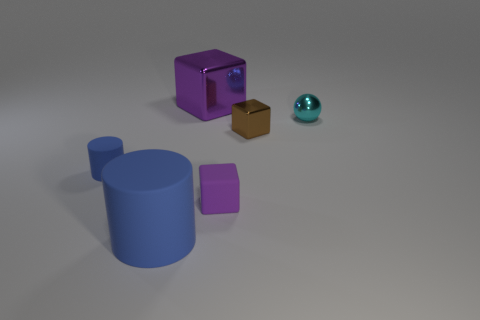There is a purple matte block; are there any big matte cylinders right of it?
Your answer should be very brief. No. What number of other objects are there of the same shape as the small blue object?
Give a very brief answer. 1. The shiny block that is the same size as the cyan sphere is what color?
Provide a succinct answer. Brown. Is the number of brown metal objects that are to the right of the tiny cyan thing less than the number of rubber objects on the left side of the small rubber cube?
Offer a very short reply. Yes. There is a blue matte object on the right side of the small thing that is left of the big metal thing; what number of blue cylinders are left of it?
Provide a short and direct response. 1. What size is the other brown metal object that is the same shape as the big metal object?
Provide a succinct answer. Small. Are there fewer purple metal things to the left of the large blue cylinder than tiny purple rubber blocks?
Provide a succinct answer. Yes. Is the shape of the brown object the same as the small purple thing?
Give a very brief answer. Yes. What is the color of the other object that is the same shape as the big matte thing?
Your answer should be very brief. Blue. What number of large cylinders are the same color as the large cube?
Your answer should be compact. 0. 